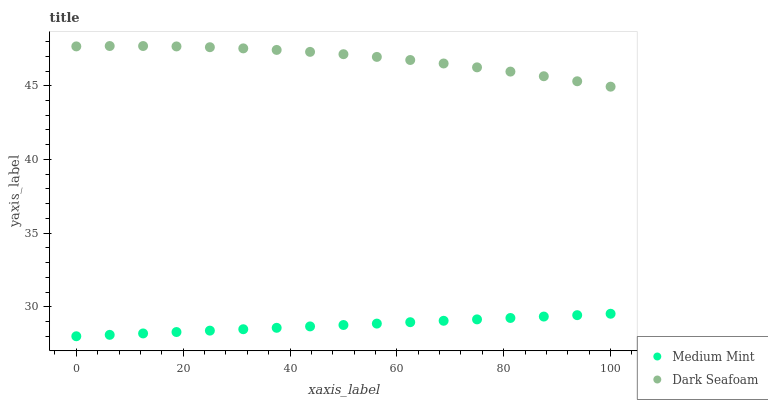Does Medium Mint have the minimum area under the curve?
Answer yes or no. Yes. Does Dark Seafoam have the maximum area under the curve?
Answer yes or no. Yes. Does Dark Seafoam have the minimum area under the curve?
Answer yes or no. No. Is Medium Mint the smoothest?
Answer yes or no. Yes. Is Dark Seafoam the roughest?
Answer yes or no. Yes. Is Dark Seafoam the smoothest?
Answer yes or no. No. Does Medium Mint have the lowest value?
Answer yes or no. Yes. Does Dark Seafoam have the lowest value?
Answer yes or no. No. Does Dark Seafoam have the highest value?
Answer yes or no. Yes. Is Medium Mint less than Dark Seafoam?
Answer yes or no. Yes. Is Dark Seafoam greater than Medium Mint?
Answer yes or no. Yes. Does Medium Mint intersect Dark Seafoam?
Answer yes or no. No. 